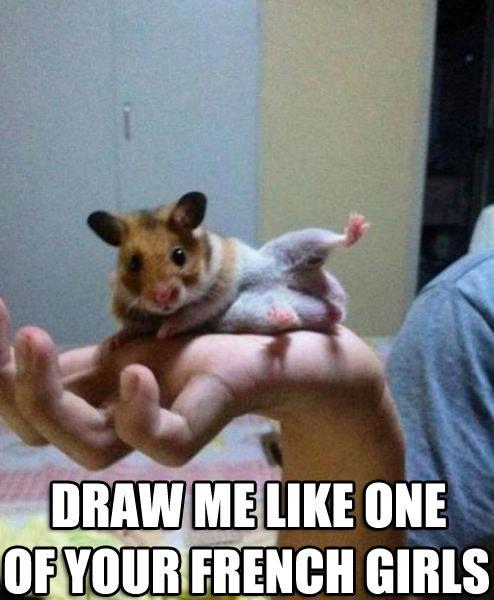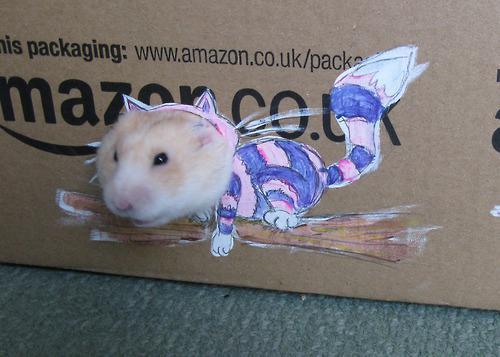The first image is the image on the left, the second image is the image on the right. Examine the images to the left and right. Is the description "There is at least one hamster playing a miniature saxophone." accurate? Answer yes or no. No. The first image is the image on the left, the second image is the image on the right. Considering the images on both sides, is "In at least one of the images there is a rodent playing an instrument" valid? Answer yes or no. No. 